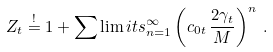<formula> <loc_0><loc_0><loc_500><loc_500>Z _ { t } \stackrel { ! } { = } 1 + \sum \lim i t s _ { n = 1 } ^ { \infty } \left ( c _ { 0 t } \, \frac { 2 \gamma _ { t } } { M } \right ) ^ { n } \, .</formula> 